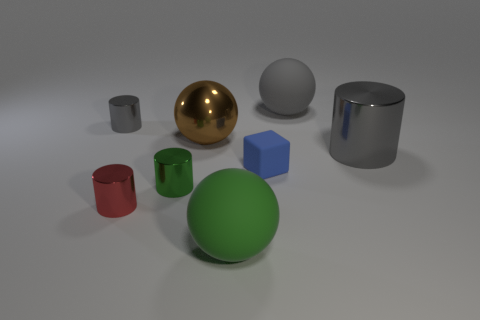Subtract all large matte spheres. How many spheres are left? 1 Subtract 3 cylinders. How many cylinders are left? 1 Subtract all brown metal things. Subtract all big green rubber things. How many objects are left? 6 Add 2 tiny gray metallic things. How many tiny gray metallic things are left? 3 Add 7 brown shiny spheres. How many brown shiny spheres exist? 8 Add 1 big brown objects. How many objects exist? 9 Subtract all green cylinders. How many cylinders are left? 3 Subtract 0 cyan blocks. How many objects are left? 8 Subtract all balls. How many objects are left? 5 Subtract all brown cylinders. Subtract all gray blocks. How many cylinders are left? 4 